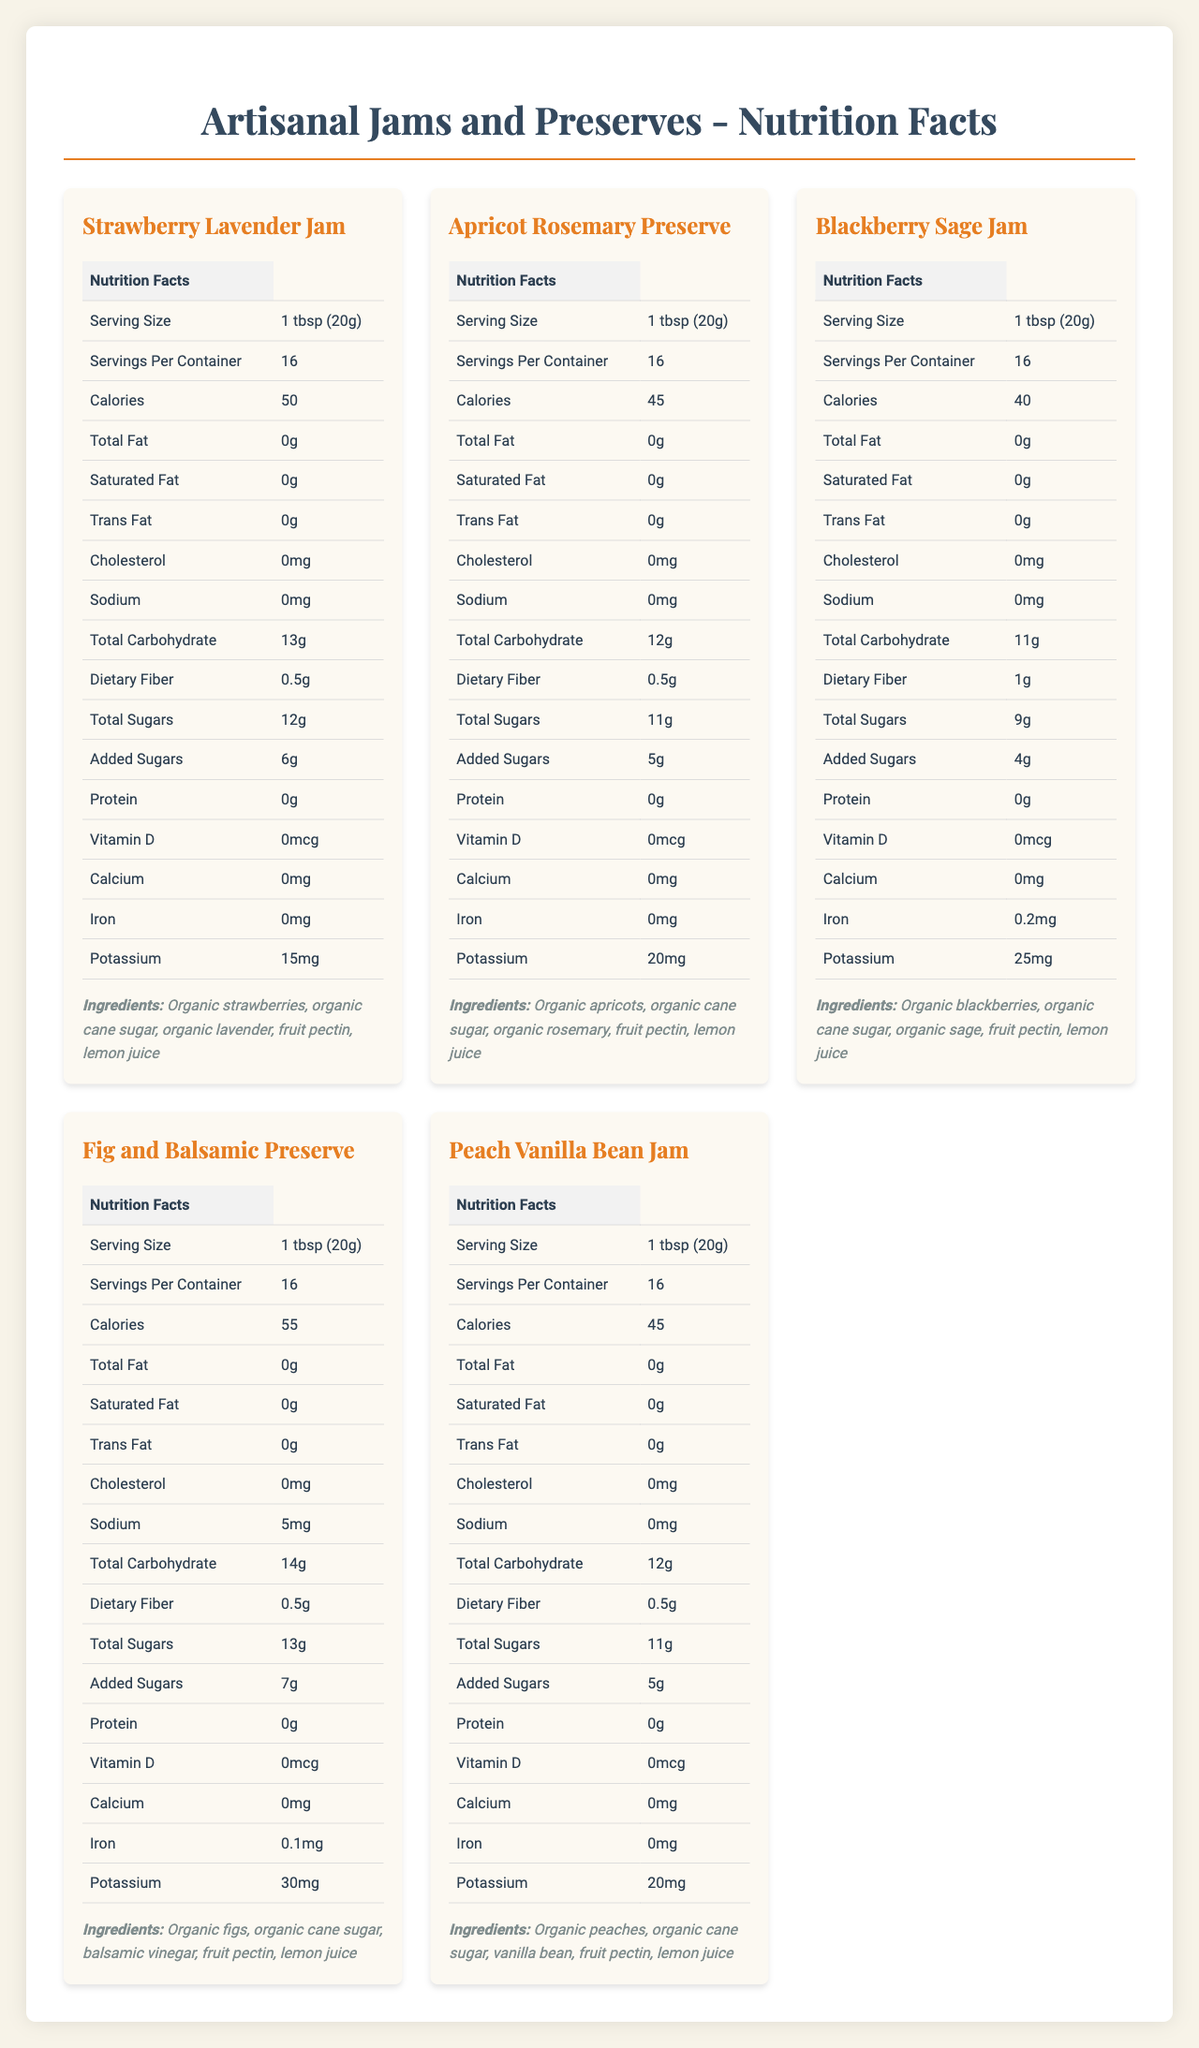How many calories are in a serving of Strawberry Lavender Jam? According to the nutrition facts for Strawberry Lavender Jam, a single serving (1 tbsp or 20g) contains 50 calories.
Answer: 50 What is the serving size for the Blackberry Sage Jam? The document indicates that the serving size for Blackberry Sage Jam is 1 tbsp (20g).
Answer: 1 tbsp (20g) How much potassium is in a serving of Apricot Rosemary Preserve? The nutrition facts for Apricot Rosemary Preserve show that it contains 20mg of potassium per serving.
Answer: 20mg Which jam contains balsamic vinegar in its ingredients? Fig and Balsamic Preserve's ingredients list includes balsamic vinegar.
Answer: Fig and Balsamic Preserve How many servings are there in one container of each jam or preserve? The nutrition facts for each jam or preserve specify that there are 16 servings per container.
Answer: 16  Fig and Balsamic Preserve has 55 calories per serving, which is the highest among the listed options.
Answer: D  Both Blackberry Sage Jam (0.2mg) and Fig and Balsamic Preserve (0.1mg) contain iron, making option D correct.
Answer: D Do any of the jams or preserves contain cholesterol? None of the jams or preserves listed in the document contain cholesterol, as each has 0mg of cholesterol per serving.
Answer: No What are the main types of nutritional information provided for each jam and preserve? The document provides extensive nutritional information for each jam and preserve, including those listed.
Answer: Serving size, servings per container, calories, total fat, saturated fat, trans fat, cholesterol, sodium, total carbohydrate, dietary fiber, total sugars, added sugars, protein, vitamin D, calcium, iron, potassium, ingredients What are the production conditions or processes used for these jams and preserves? The document does not provide any information about the production conditions or processes for the jams and preserves.
Answer: Cannot be determined 